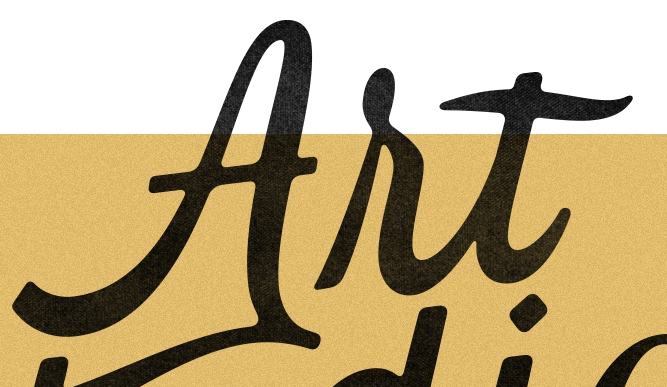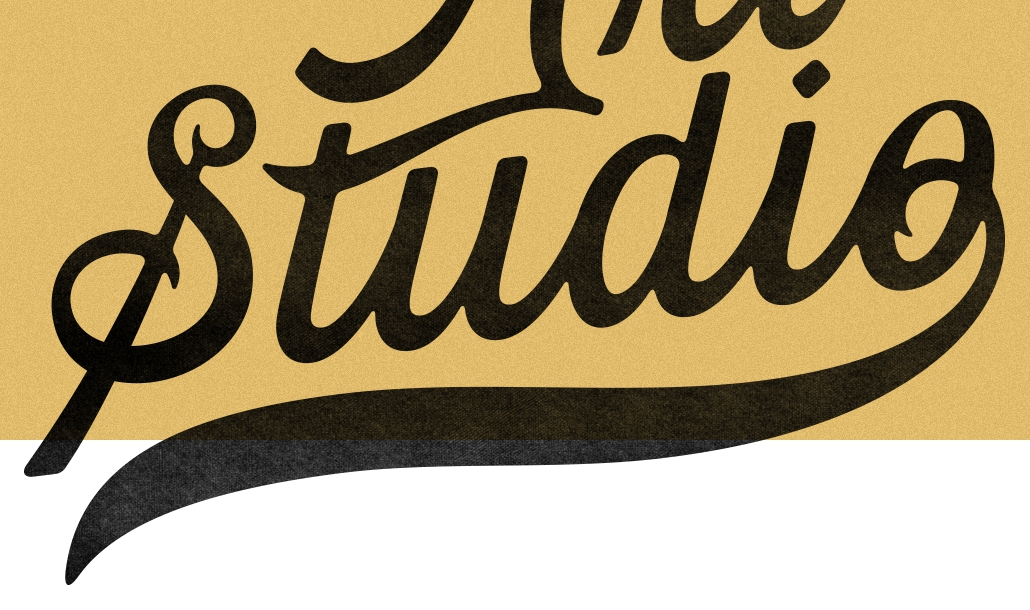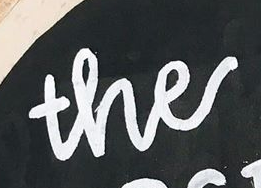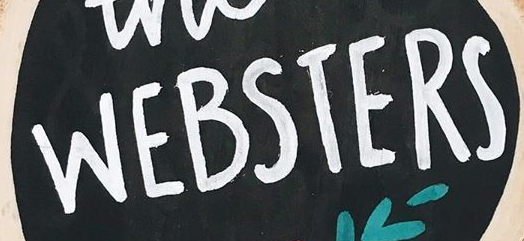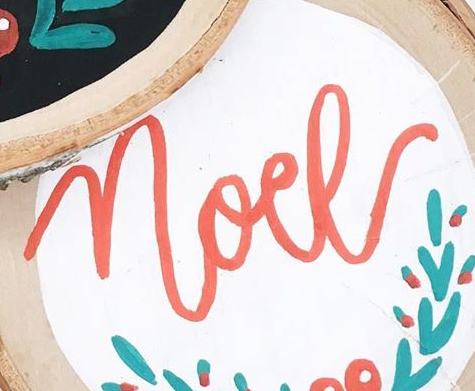What words are shown in these images in order, separated by a semicolon? Art; Studio; the; WEBSTERS; noel 